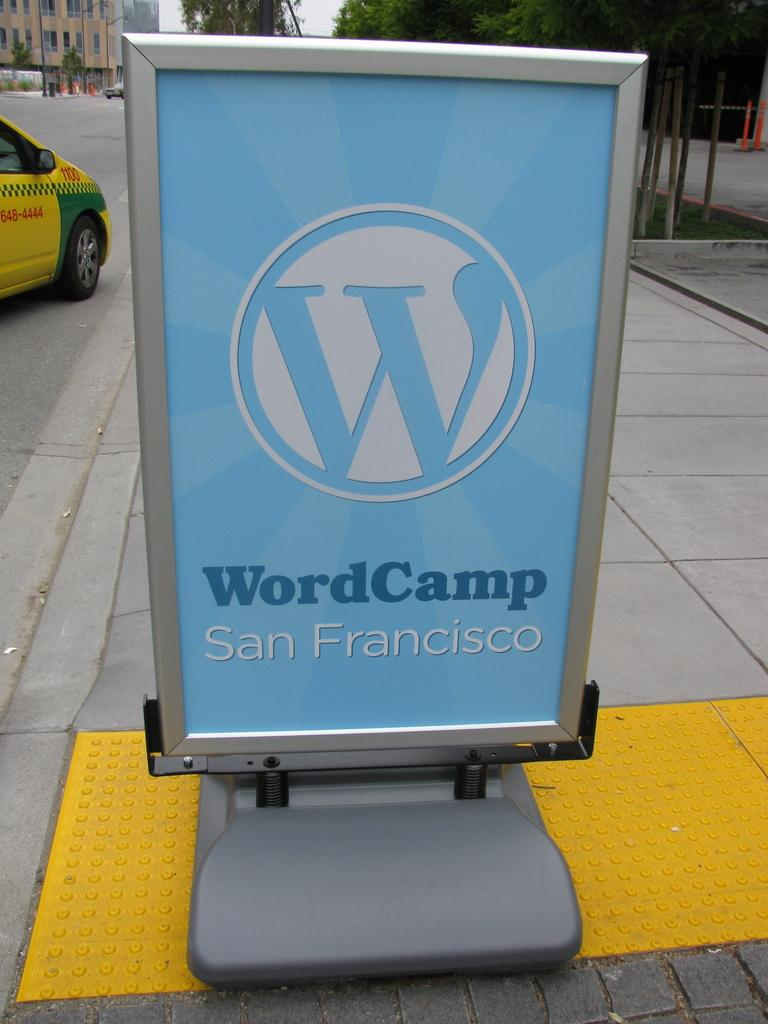<image>
Share a concise interpretation of the image provided. A portable sign identifies the San Francisco location of the WordCamp event. 